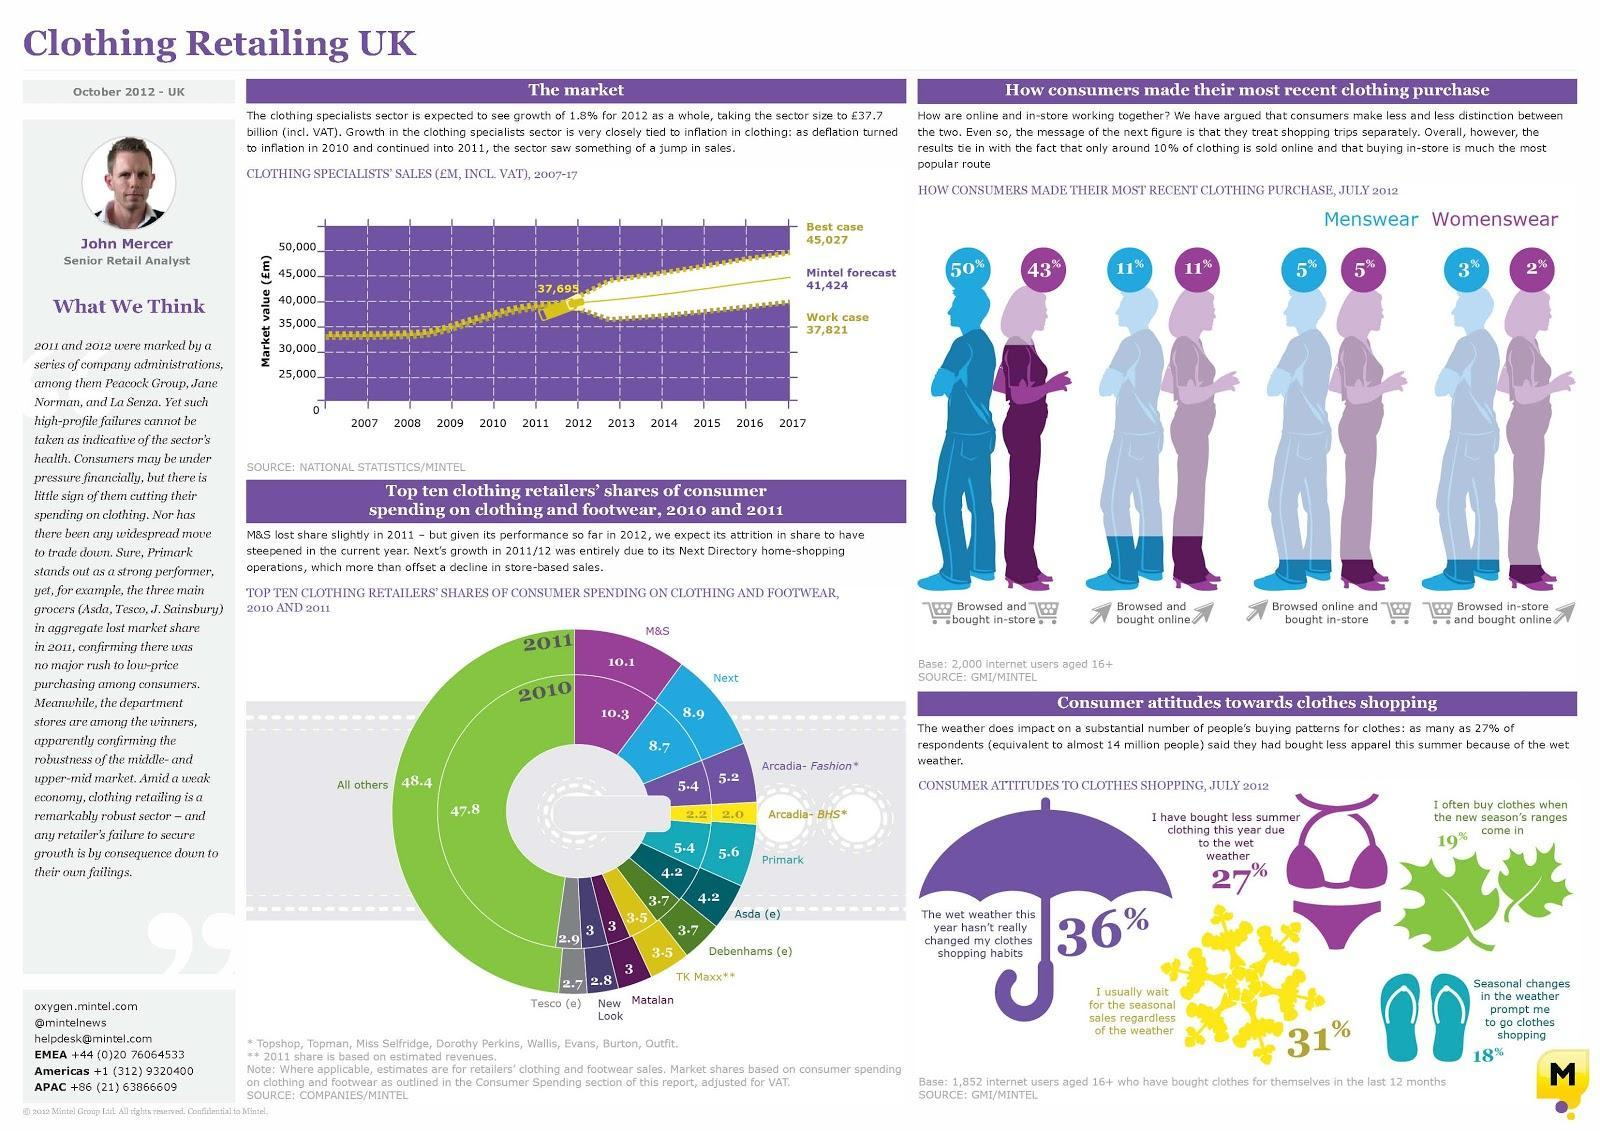What is the share of consumer spending of Asda in 2011?
Answer the question with a short phrase. 4.2 What percentage of menswear was browsed online & bought in-store by the customers in July 2012? 5% What percentage of womenswear was browsed & bought online by the customers in July 2012? 11% What is the share of consumer spending of Primark in 2010? 5.4 What percentage of womenswear was browsed & bought in-store by the customers in July 2012? 43% What is the share of consumer spending of Tesco in 2011? 2.7 What percentage of menswear was browsed in-store & bought online by the customers in July 2012? 3% 